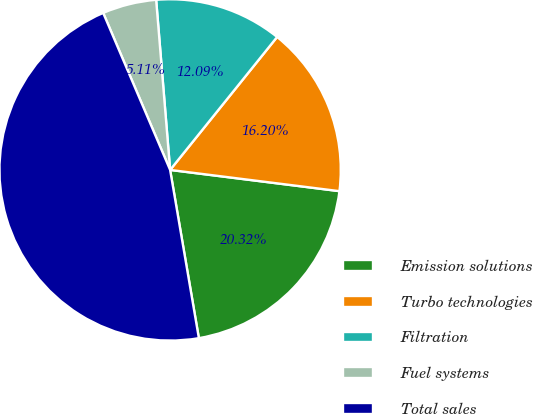Convert chart to OTSL. <chart><loc_0><loc_0><loc_500><loc_500><pie_chart><fcel>Emission solutions<fcel>Turbo technologies<fcel>Filtration<fcel>Fuel systems<fcel>Total sales<nl><fcel>20.32%<fcel>16.2%<fcel>12.09%<fcel>5.11%<fcel>46.28%<nl></chart> 